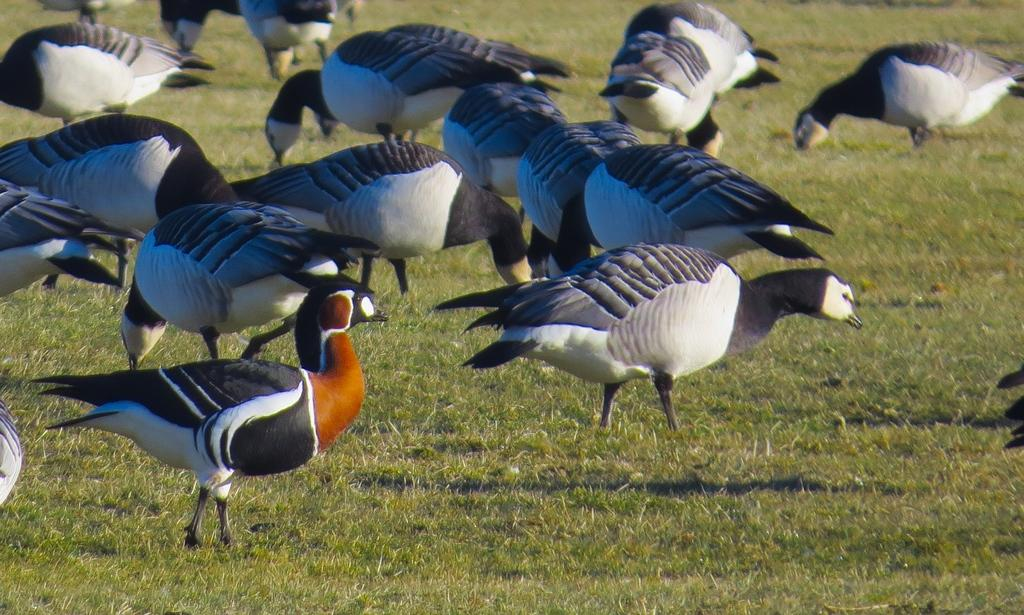What type of ground is visible in the image? The ground in the image is covered with grass. What is present on the grassy ground? There are words or objects standing on the grass ground. How many deer can be seen grazing on the grass in the image? There are no deer present in the image; it only features words or objects on the grassy ground. 